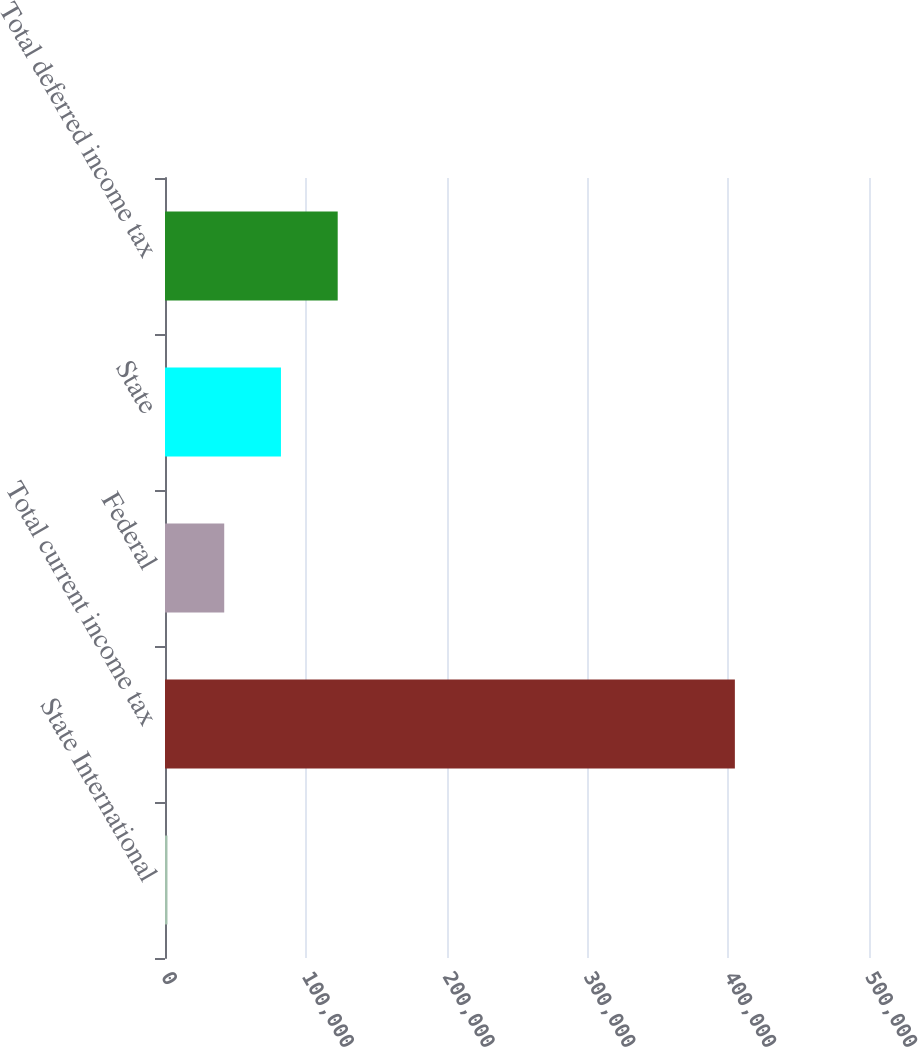Convert chart to OTSL. <chart><loc_0><loc_0><loc_500><loc_500><bar_chart><fcel>State International<fcel>Total current income tax<fcel>Federal<fcel>State<fcel>Total deferred income tax<nl><fcel>1764<fcel>404737<fcel>42061.3<fcel>82358.6<fcel>122656<nl></chart> 